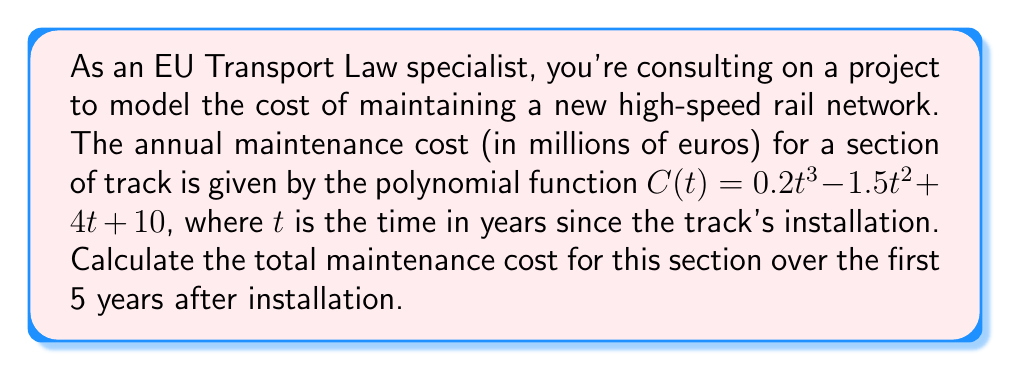Give your solution to this math problem. To find the total maintenance cost over 5 years, we need to calculate the definite integral of the cost function from $t=0$ to $t=5$. This represents the area under the curve of $C(t)$ from 0 to 5.

1) The integral of $C(t)$ is:
   $$\int C(t) dt = \int (0.2t^3 - 1.5t^2 + 4t + 10) dt$$

2) Integrating each term:
   $$\int C(t) dt = 0.05t^4 - 0.5t^3 + 2t^2 + 10t + K$$

3) We don't need to worry about the constant of integration $K$ as it will cancel out when we evaluate the definite integral.

4) Now, we evaluate this from 0 to 5:
   $$\int_0^5 C(t) dt = [0.05t^4 - 0.5t^3 + 2t^2 + 10t]_0^5$$

5) Substituting $t=5$ and $t=0$:
   $$(0.05(5^4) - 0.5(5^3) + 2(5^2) + 10(5)) - (0.05(0^4) - 0.5(0^3) + 2(0^2) + 10(0))$$

6) Simplifying:
   $$(312.5 - 62.5 + 50 + 50) - 0 = 350$$

Therefore, the total maintenance cost over 5 years is 350 million euros.
Answer: 350 million euros 